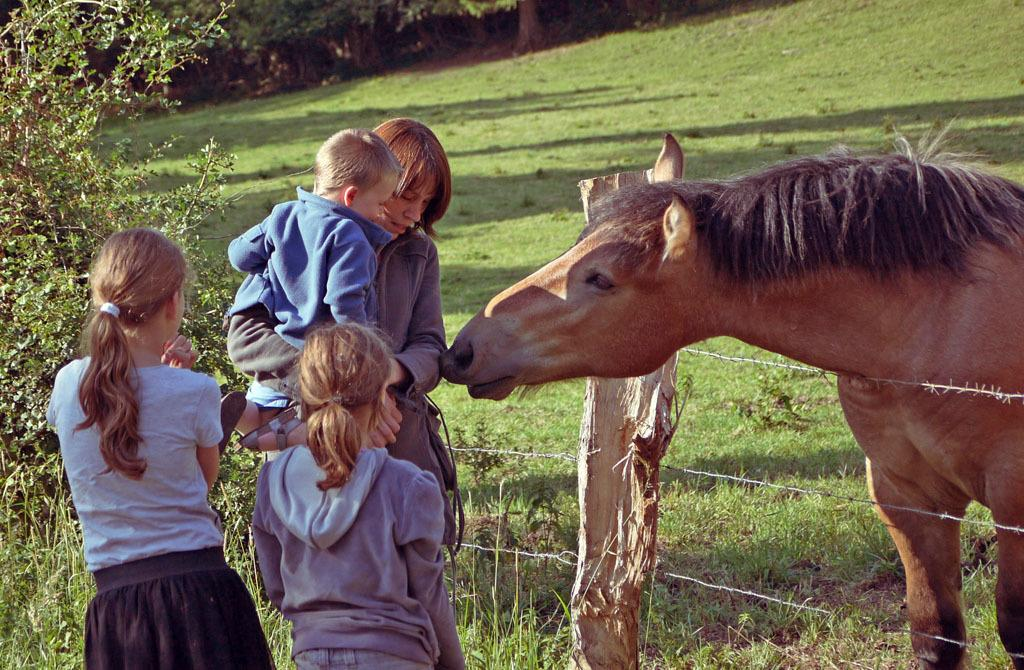How many people are on the left side of the image? There are four people on the left side of the image. What is located on the right side of the image? There is a horse on the right side of the image. What is the horse standing next to? The horse is next to a fence. What type of vegetation is visible below the people and the horse? Grass is visible below the people and the horse. What can be seen in the background of the image? There are many trees in the background of the image. What type of pain is the horse experiencing in the image? There is no indication in the image that the horse is experiencing any pain. What type of skin condition can be seen on the people in the image? There is no information about the people's skin conditions in the image. 